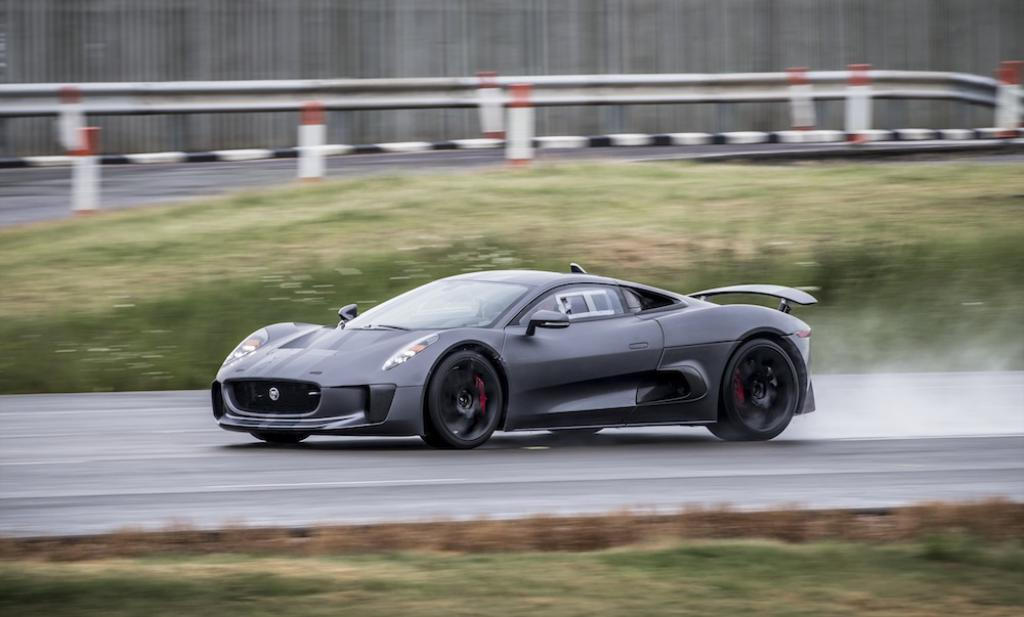What is the main subject of the image? There is a car on the road in the image. What type of vegetation can be seen in the image? There is grass visible in the image. How would you describe the background of the image? The background of the image is blurry. What type of church can be seen in the background of the image? There is no church present in the image; the background is blurry. Is there a battle taking place in the image? There is no indication of a battle in the image, as it features a car on the road and grass. 